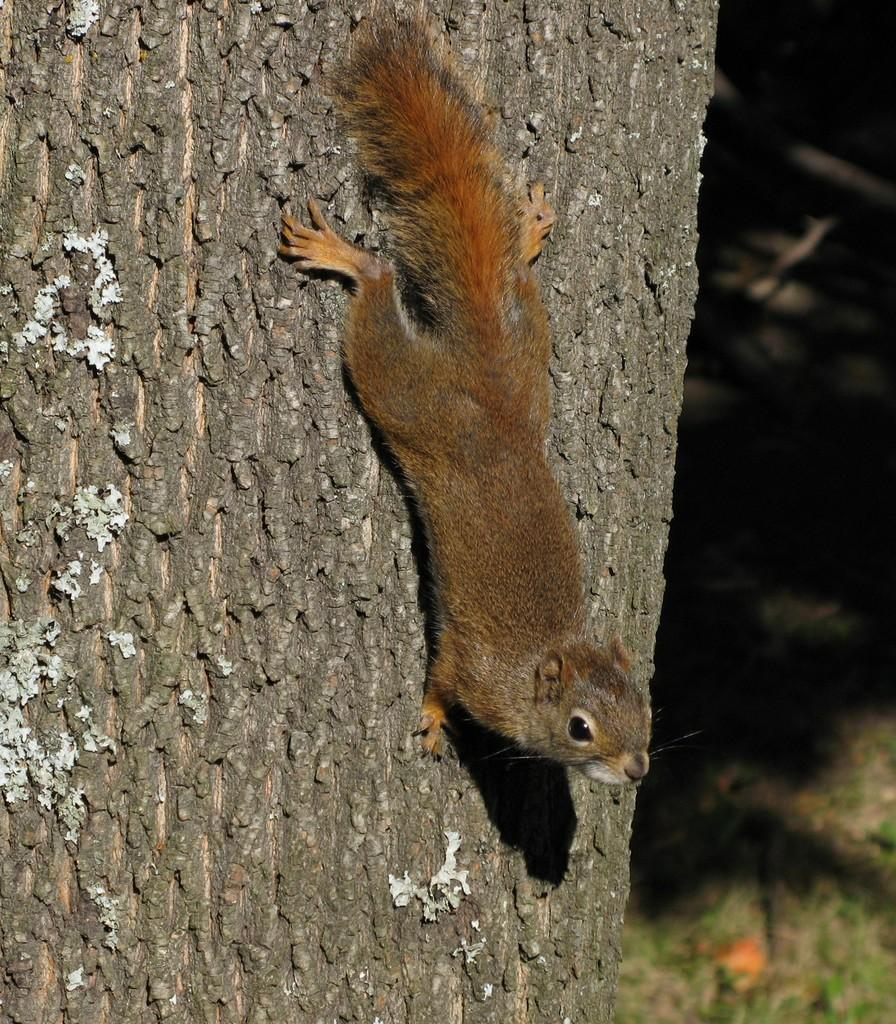What animal is in the foreground of the image? There is a squirrel in the foreground of the image. Where is the squirrel located? The squirrel is on a tree trunk. What type of vegetation can be seen in the background of the image? There is grass visible in the background of the image. What type of vegetation can be seen in the background of the image? There is grass visible in the background of the image. What type of environment might the image have been taken in? The image may have been taken in a forest. How many bikes are parked next to the squirrel in the image? There are no bikes present in the image; it features a squirrel on a tree trunk. What type of horn can be heard in the background of the image? There is no sound or horn present in the image; it is a still image of a squirrel on a tree trunk. 